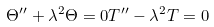<formula> <loc_0><loc_0><loc_500><loc_500>\Theta ^ { \prime \prime } + \lambda ^ { 2 } \Theta = 0 T ^ { \prime \prime } - \lambda ^ { 2 } T = 0</formula> 